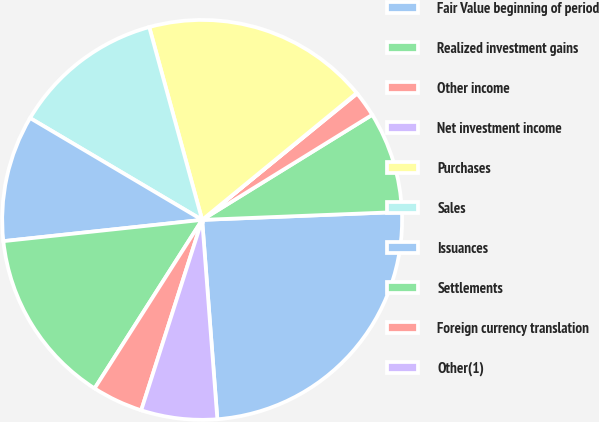<chart> <loc_0><loc_0><loc_500><loc_500><pie_chart><fcel>Fair Value beginning of period<fcel>Realized investment gains<fcel>Other income<fcel>Net investment income<fcel>Purchases<fcel>Sales<fcel>Issuances<fcel>Settlements<fcel>Foreign currency translation<fcel>Other(1)<nl><fcel>24.42%<fcel>8.17%<fcel>2.08%<fcel>0.05%<fcel>18.32%<fcel>12.23%<fcel>10.2%<fcel>14.26%<fcel>4.11%<fcel>6.14%<nl></chart> 